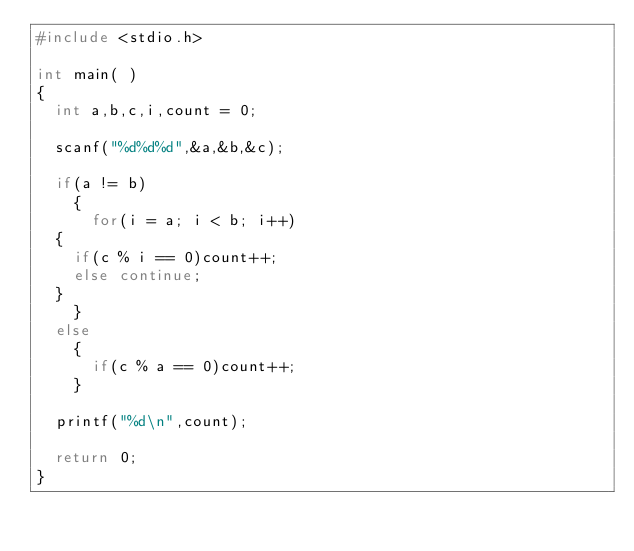<code> <loc_0><loc_0><loc_500><loc_500><_C_>#include <stdio.h>

int main( )
{
  int a,b,c,i,count = 0;

  scanf("%d%d%d",&a,&b,&c);

  if(a != b)
    {
      for(i = a; i < b; i++)
	{
	  if(c % i == 0)count++;
	  else continue;
	}
    }
  else
    {
      if(c % a == 0)count++;
    }

  printf("%d\n",count);

  return 0;
}</code> 